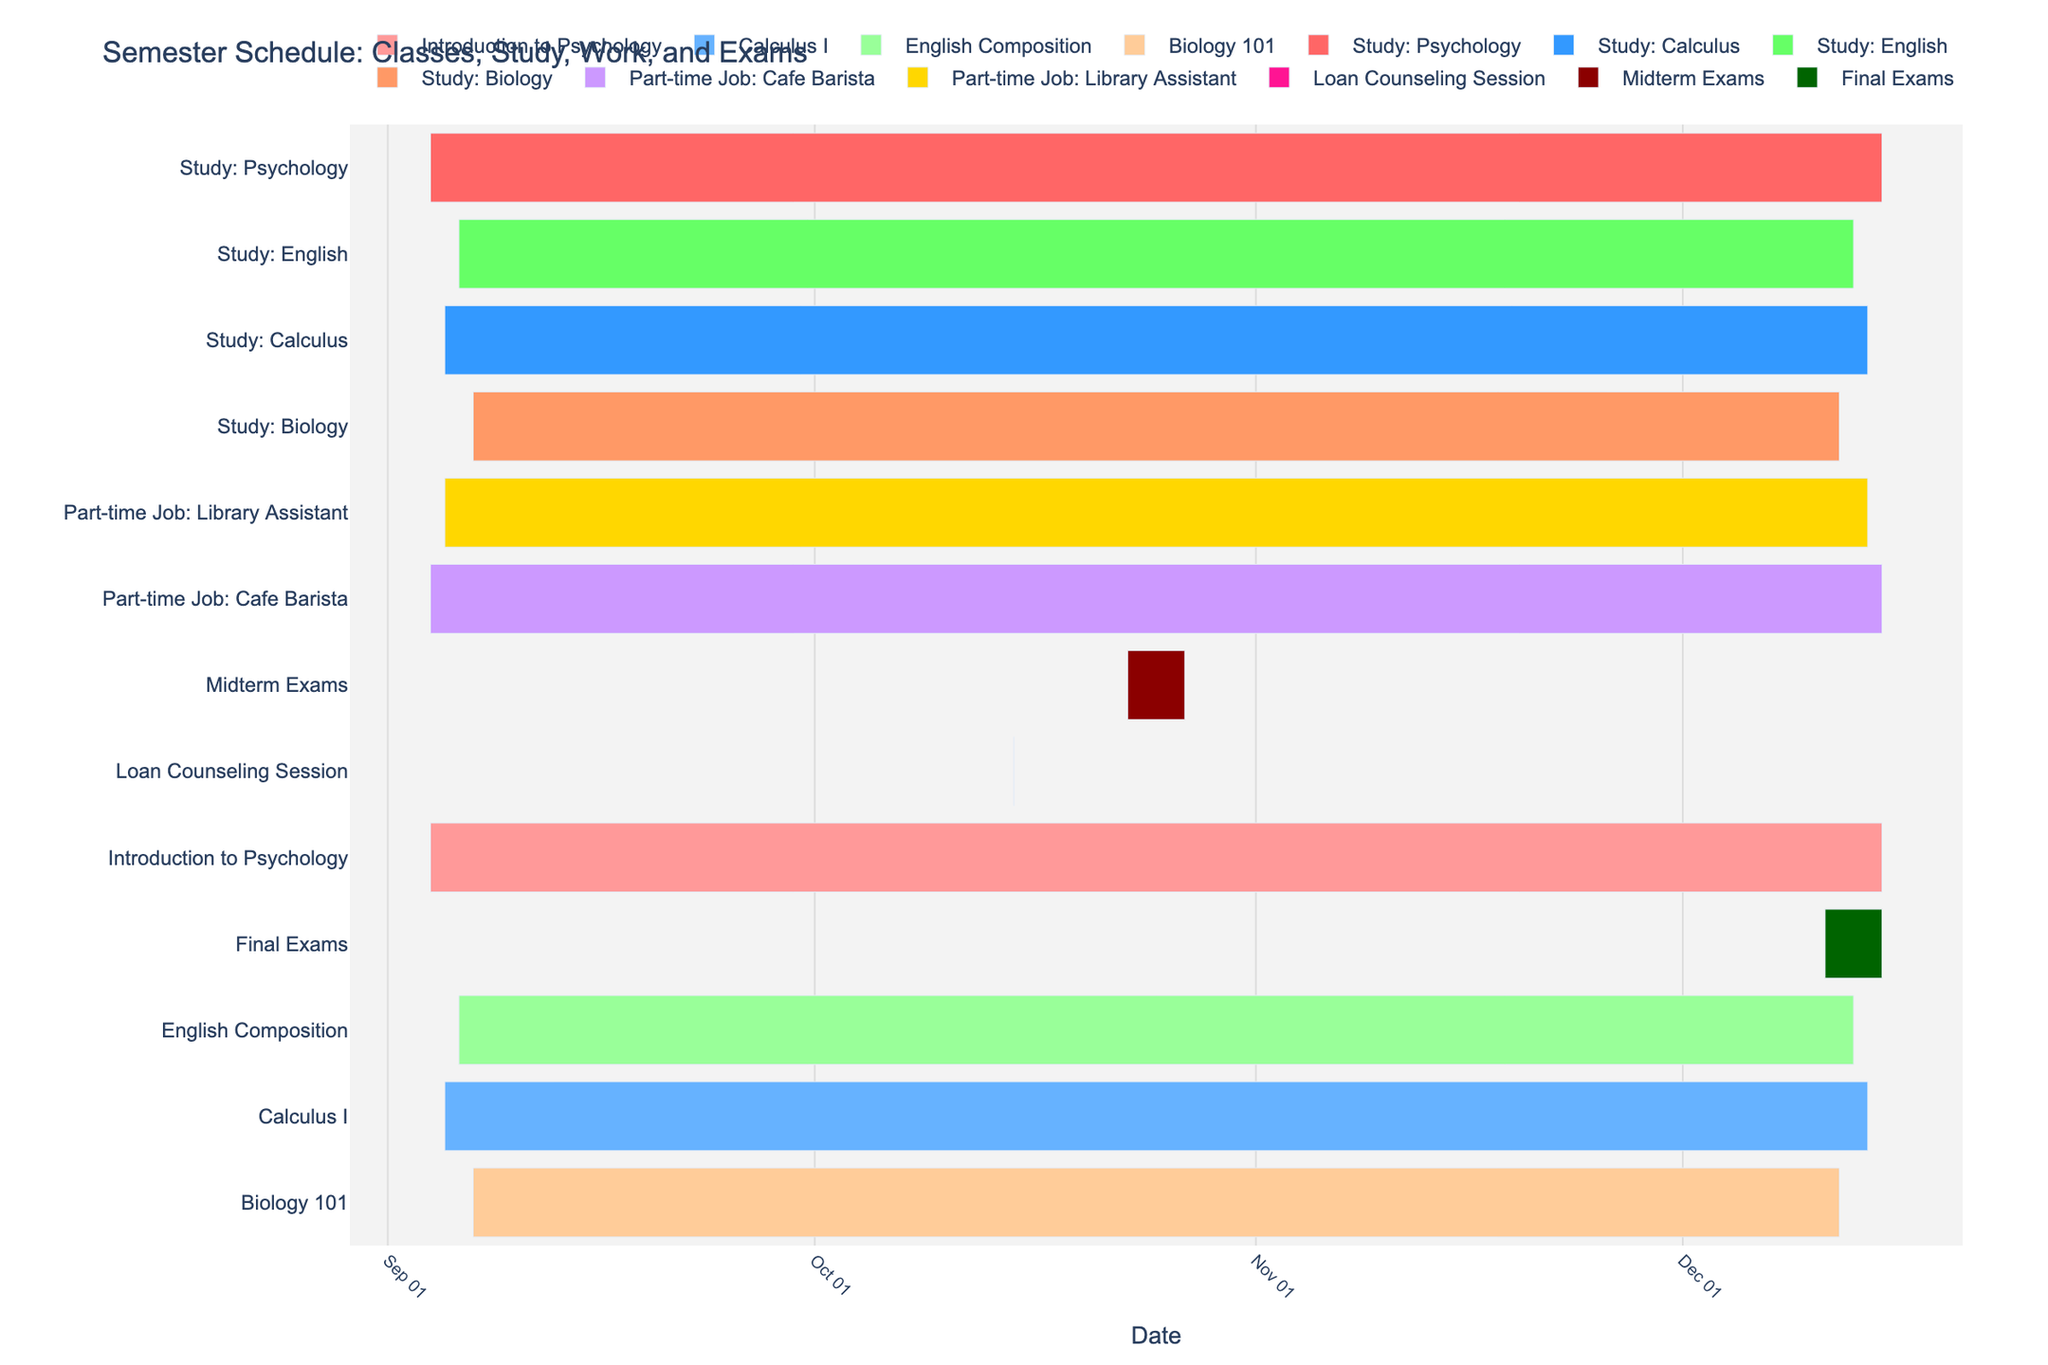What's the title of the Gantt Chart? The title of the Gantt Chart is displayed prominently at the top. It reads "Semester Schedule: Classes, Study, Work, and Exams."
Answer: Semester Schedule: Classes, Study, Work, and Exams Which task ends the latest in the semester? To find the task that ends the latest in the semester, look at the end dates on the x-axis and find the task that extends the furthest to the right. The latest end date is December 15, 2023, and multiple tasks end on that day.
Answer: Introduction to Psychology, Study: Psychology, Part-time Job: Cafe Barista How long is the Calculus I class scheduled to run? To find the duration of the Calculus I class, check the start and end dates listed for it. Calculus I starts on September 5, 2023, and ends on December 14, 2023. The length of the period can be calculated from these dates.
Answer: September 5 to December 14 What tasks have the same duration? To identify tasks with the same duration, look for tasks with identical start and end dates on the chart. Both Introduction to Psychology and Study: Psychology run from September 4, 2023, to December 15, 2023.
Answer: Introduction to Psychology, Study: Psychology Which study session has the shortest duration? Compare the start and end dates of all study sessions. Biology study sessions have the shortest duration starting on September 7 and ending on December 12, 2023.
Answer: Study: Biology Are there any tasks that overlap with Midterm Exams? Look at the dates for the Midterm Exams (October 23-27, 2023) and see which tasks' duration overlaps with this period. Since Midterm Exams are within the semester, almost all tasks overlap with them.
Answer: Most classes, study sessions, and part-time jobs What's the total number of tasks shown in the Gantt Chart? Count the number of distinct tasks displayed on the y-axis of the chart. There are 13 unique tasks listed in the chart.
Answer: 13 What are the colors used to represent Study sessions? The distinct colors for Study sessions can be identified by referencing the chart's color mapping. Study: Psychology is dark red, Study: Calculus is blue, Study: English is green, and Study: Biology is orange.
Answer: Dark red, blue, green, orange Which part-time job has a later end date? Compare the end dates for both part-time jobs listed. The Cafe Barista job ends on December 15, 2023, which is later than the Library Assistant job ending on December 14, 2023.
Answer: Cafe Barista When is the Loan Counseling Session scheduled? The Loan Counseling Session is marked on the timeline and occurs on a single date, October 15, 2023.
Answer: October 15, 2023 